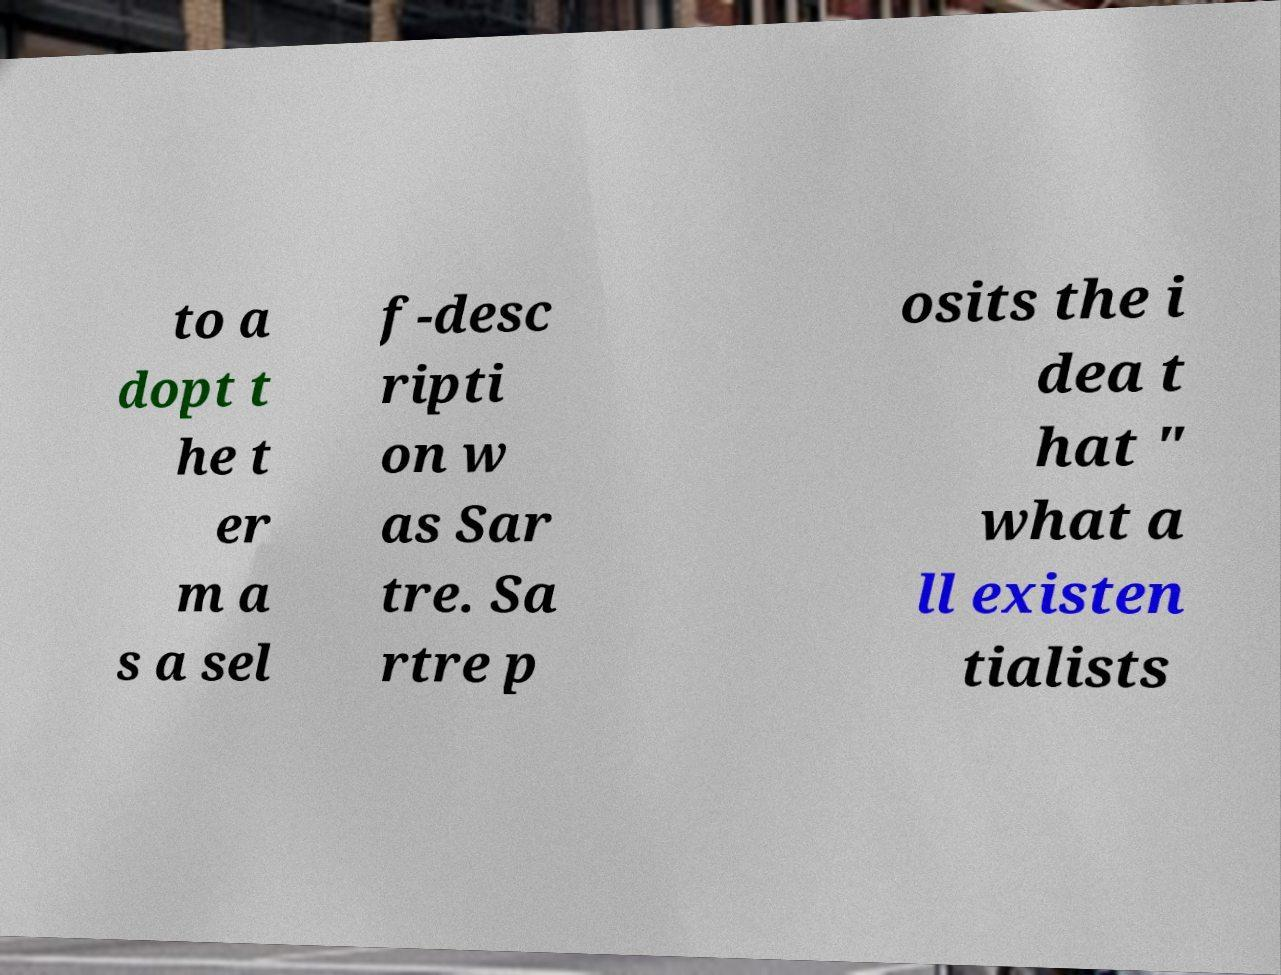There's text embedded in this image that I need extracted. Can you transcribe it verbatim? to a dopt t he t er m a s a sel f-desc ripti on w as Sar tre. Sa rtre p osits the i dea t hat " what a ll existen tialists 